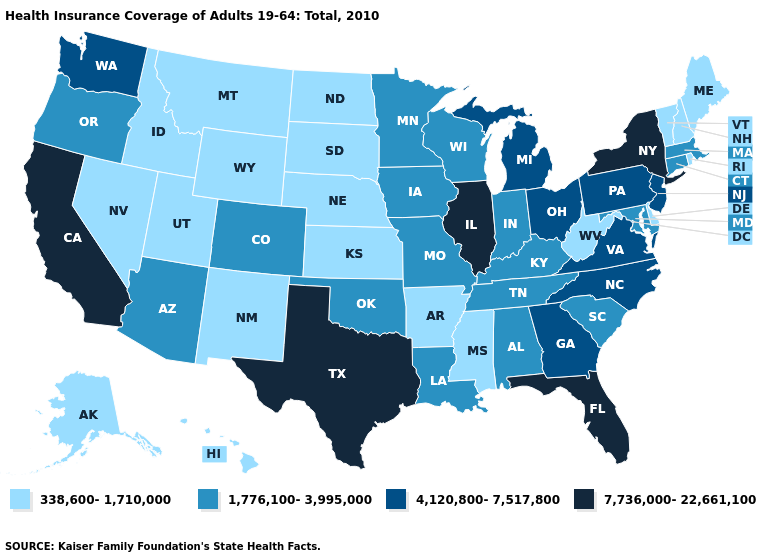What is the value of Maryland?
Concise answer only. 1,776,100-3,995,000. Name the states that have a value in the range 4,120,800-7,517,800?
Answer briefly. Georgia, Michigan, New Jersey, North Carolina, Ohio, Pennsylvania, Virginia, Washington. Does the first symbol in the legend represent the smallest category?
Short answer required. Yes. Name the states that have a value in the range 4,120,800-7,517,800?
Quick response, please. Georgia, Michigan, New Jersey, North Carolina, Ohio, Pennsylvania, Virginia, Washington. What is the highest value in states that border Rhode Island?
Answer briefly. 1,776,100-3,995,000. Among the states that border Indiana , which have the highest value?
Give a very brief answer. Illinois. What is the lowest value in the MidWest?
Short answer required. 338,600-1,710,000. What is the highest value in the USA?
Short answer required. 7,736,000-22,661,100. Does Missouri have a lower value than Ohio?
Short answer required. Yes. Does the first symbol in the legend represent the smallest category?
Short answer required. Yes. Which states have the highest value in the USA?
Concise answer only. California, Florida, Illinois, New York, Texas. What is the value of New Mexico?
Answer briefly. 338,600-1,710,000. What is the value of Maine?
Short answer required. 338,600-1,710,000. Name the states that have a value in the range 7,736,000-22,661,100?
Write a very short answer. California, Florida, Illinois, New York, Texas. What is the value of Kentucky?
Write a very short answer. 1,776,100-3,995,000. 